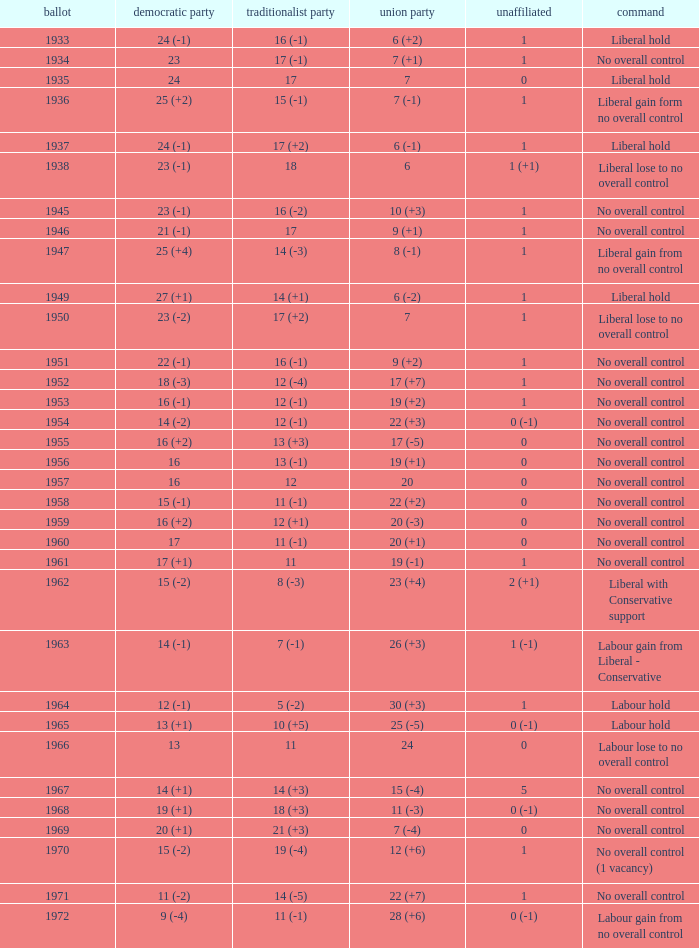Who was in control the year that Labour Party won 12 (+6) seats? No overall control (1 vacancy). 